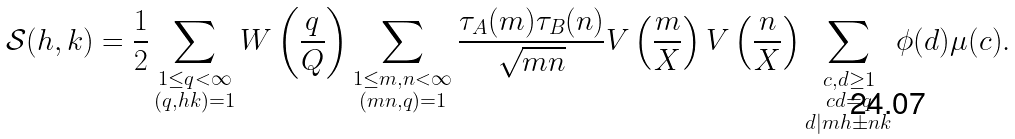<formula> <loc_0><loc_0><loc_500><loc_500>\mathcal { S } ( h , k ) = \frac { 1 } { 2 } \sum _ { \substack { 1 \leq q < \infty \\ ( q , h k ) = 1 } } W \left ( \frac { q } { Q } \right ) \sum _ { \substack { 1 \leq m , n < \infty \\ ( m n , q ) = 1 } } \frac { \tau _ { A } ( m ) \tau _ { B } ( n ) } { \sqrt { m n } } V \left ( \frac { m } { X } \right ) V \left ( \frac { n } { X } \right ) \sum _ { \substack { c , d \geq 1 \\ c d = q \\ d | m h \pm n k } } \phi ( d ) \mu ( c ) .</formula> 